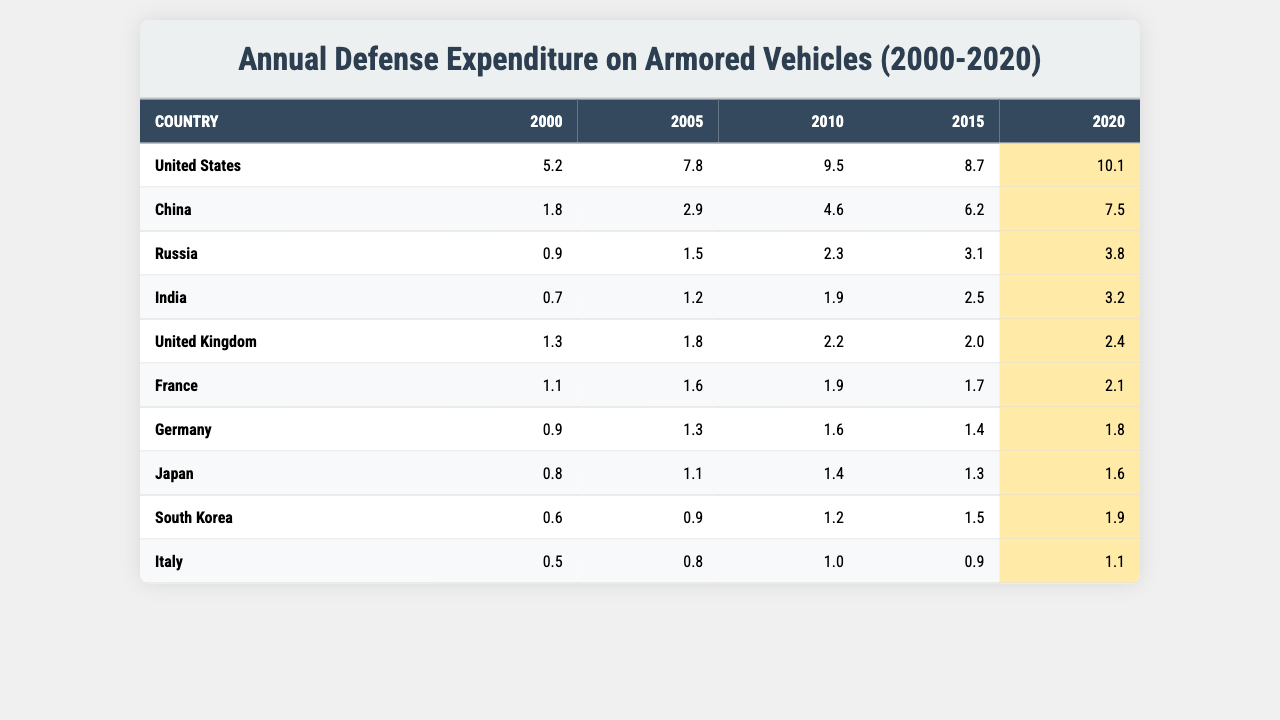What was the highest defense expenditure on armored vehicles in 2020? By examining the 2020 column, the United States shows the highest value of 10.1 billion USD, which is greater than any other country listed.
Answer: 10.1 billion USD Which country had an expenditure of 1.8 billion USD in 2005? Looking at the 2005 data, China is identified as having an expenditure of 2.9 billion USD, but the only country that corresponds directly to 1.8 billion USD is the United Kingdom.
Answer: United Kingdom What is the total defense expenditure on armored vehicles by Russia from 2000 to 2020? The values for Russia are summed as follows: 0.9 + 1.5 + 2.3 + 3.1 + 3.8, resulting in a total of 11.6 billion USD.
Answer: 11.6 billion USD Did India's defense expenditure on armored vehicles increase every year from 2000 to 2020? By observing the yearly figures, each subsequent year reflects an increase: 0.7 (2000), 1.2 (2005), 1.9 (2010), 2.5 (2015), and 3.2 (2020), confirming that the expenditure did consistently rise.
Answer: Yes What was the average expenditure of all countries in 2010? To calculate the average, sum all countries' expenditures for 2010 which are: 9.5 (USA) + 4.6 (China) + 2.3 (Russia) + 1.9 (India) + 2.2 (UK) + 1.9 (France) + 1.6 (Germany) + 1.4 (Japan) + 1.2 (South Korea) + 1.0 (Italy) = 28.9 billion USD. Dividing that by the total number of countries (10) gives an average of 2.89 billion USD.
Answer: 2.89 billion USD Which country experienced the smallest increase in armor vehicle expenditures from 2015 to 2020? Analyzing the changes from 2015 to 2020, the expenditures are: (USA: 8.7 to 10.1 = +1.4), (China: 6.2 to 7.5 = +1.3), (Russia: 3.1 to 3.8 = +0.7), (India: 2.5 to 3.2 = +0.7), (UK: 2.0 to 2.4 = +0.4), (France: 1.7 to 2.1 = +0.4), (Germany: 1.4 to 1.8 = +0.4), (Japan: 1.3 to 1.6 = +0.3), (South Korea: 1.5 to 1.9 = +0.4), (Italy: 0.9 to 1.1 = +0.2). The country with the smallest increase is **Italy** with an increase of 0.2 billion USD.
Answer: Italy 